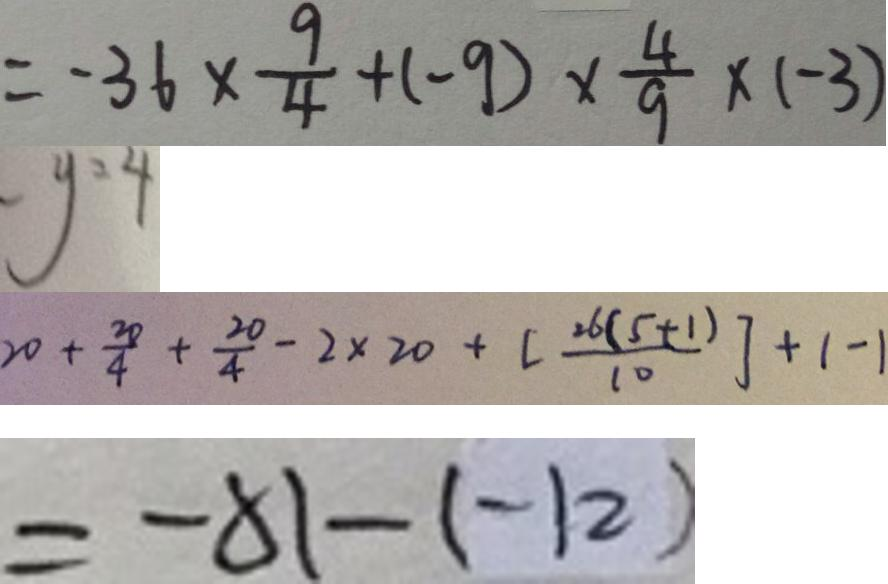<formula> <loc_0><loc_0><loc_500><loc_500>= - 3 6 \times \frac { 9 } { 4 } + ( - 9 ) \times \frac { 4 } { 9 } \times ( - 3 ) 
 y = 4 
 2 0 + \frac { 2 0 } { 4 } + \frac { 2 0 } { 4 } - 2 \times 2 0 + [ \frac { 2 6 ( 5 + 1 ) } { 1 0 } ] + 1 - 1 
 = - 8 1 - ( - 1 2 )</formula> 